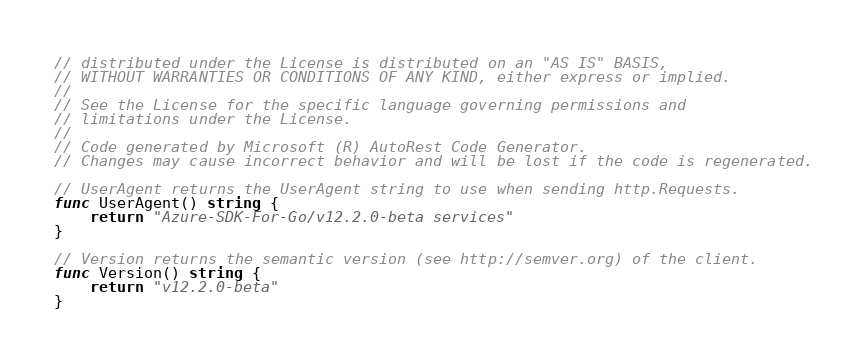<code> <loc_0><loc_0><loc_500><loc_500><_Go_>// distributed under the License is distributed on an "AS IS" BASIS,
// WITHOUT WARRANTIES OR CONDITIONS OF ANY KIND, either express or implied.
//
// See the License for the specific language governing permissions and
// limitations under the License.
//
// Code generated by Microsoft (R) AutoRest Code Generator.
// Changes may cause incorrect behavior and will be lost if the code is regenerated.

// UserAgent returns the UserAgent string to use when sending http.Requests.
func UserAgent() string {
	return "Azure-SDK-For-Go/v12.2.0-beta services"
}

// Version returns the semantic version (see http://semver.org) of the client.
func Version() string {
	return "v12.2.0-beta"
}
</code> 